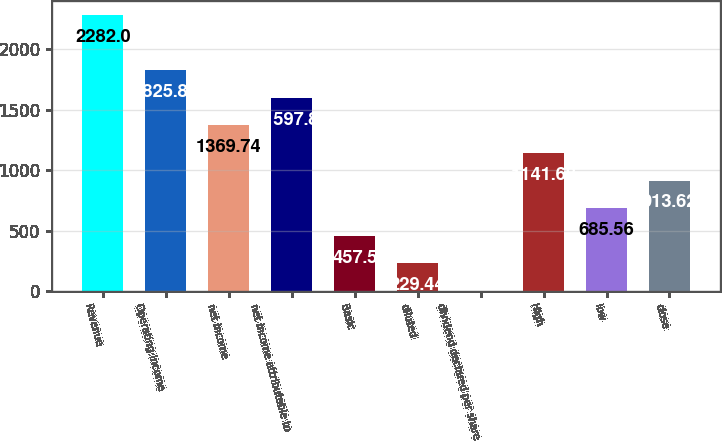Convert chart. <chart><loc_0><loc_0><loc_500><loc_500><bar_chart><fcel>Revenue<fcel>Operating income<fcel>net income<fcel>net income attributable to<fcel>Basic<fcel>diluted<fcel>dividend declared per share<fcel>High<fcel>low<fcel>close<nl><fcel>2282<fcel>1825.86<fcel>1369.74<fcel>1597.8<fcel>457.5<fcel>229.44<fcel>1.38<fcel>1141.68<fcel>685.56<fcel>913.62<nl></chart> 